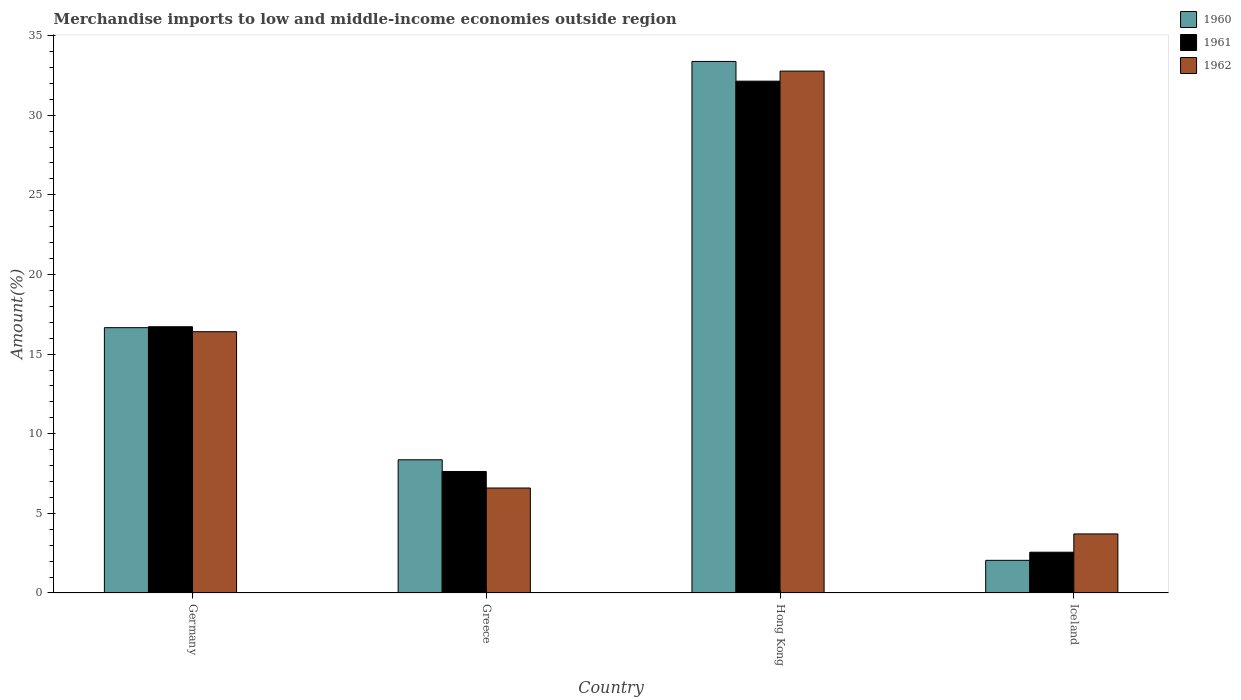How many different coloured bars are there?
Keep it short and to the point. 3. How many groups of bars are there?
Provide a succinct answer. 4. How many bars are there on the 4th tick from the left?
Offer a terse response. 3. What is the label of the 2nd group of bars from the left?
Your response must be concise. Greece. In how many cases, is the number of bars for a given country not equal to the number of legend labels?
Your response must be concise. 0. What is the percentage of amount earned from merchandise imports in 1960 in Greece?
Your response must be concise. 8.36. Across all countries, what is the maximum percentage of amount earned from merchandise imports in 1962?
Your answer should be very brief. 32.77. Across all countries, what is the minimum percentage of amount earned from merchandise imports in 1960?
Make the answer very short. 2.05. In which country was the percentage of amount earned from merchandise imports in 1962 maximum?
Your response must be concise. Hong Kong. In which country was the percentage of amount earned from merchandise imports in 1960 minimum?
Keep it short and to the point. Iceland. What is the total percentage of amount earned from merchandise imports in 1960 in the graph?
Keep it short and to the point. 60.44. What is the difference between the percentage of amount earned from merchandise imports in 1961 in Greece and that in Iceland?
Keep it short and to the point. 5.07. What is the difference between the percentage of amount earned from merchandise imports in 1960 in Greece and the percentage of amount earned from merchandise imports in 1962 in Germany?
Offer a terse response. -8.04. What is the average percentage of amount earned from merchandise imports in 1960 per country?
Your answer should be compact. 15.11. What is the difference between the percentage of amount earned from merchandise imports of/in 1962 and percentage of amount earned from merchandise imports of/in 1960 in Germany?
Your answer should be very brief. -0.25. What is the ratio of the percentage of amount earned from merchandise imports in 1962 in Germany to that in Hong Kong?
Keep it short and to the point. 0.5. Is the difference between the percentage of amount earned from merchandise imports in 1962 in Germany and Iceland greater than the difference between the percentage of amount earned from merchandise imports in 1960 in Germany and Iceland?
Keep it short and to the point. No. What is the difference between the highest and the second highest percentage of amount earned from merchandise imports in 1961?
Ensure brevity in your answer.  15.42. What is the difference between the highest and the lowest percentage of amount earned from merchandise imports in 1960?
Give a very brief answer. 31.32. What does the 2nd bar from the left in Greece represents?
Offer a terse response. 1961. What does the 2nd bar from the right in Hong Kong represents?
Your answer should be compact. 1961. How many bars are there?
Provide a succinct answer. 12. Are all the bars in the graph horizontal?
Your response must be concise. No. How many countries are there in the graph?
Your answer should be very brief. 4. What is the difference between two consecutive major ticks on the Y-axis?
Keep it short and to the point. 5. Does the graph contain grids?
Provide a succinct answer. No. Where does the legend appear in the graph?
Offer a terse response. Top right. How many legend labels are there?
Your answer should be very brief. 3. How are the legend labels stacked?
Offer a very short reply. Vertical. What is the title of the graph?
Give a very brief answer. Merchandise imports to low and middle-income economies outside region. Does "1974" appear as one of the legend labels in the graph?
Your answer should be very brief. No. What is the label or title of the X-axis?
Provide a succinct answer. Country. What is the label or title of the Y-axis?
Your response must be concise. Amount(%). What is the Amount(%) of 1960 in Germany?
Offer a terse response. 16.66. What is the Amount(%) of 1961 in Germany?
Provide a succinct answer. 16.72. What is the Amount(%) of 1962 in Germany?
Give a very brief answer. 16.41. What is the Amount(%) in 1960 in Greece?
Your response must be concise. 8.36. What is the Amount(%) of 1961 in Greece?
Keep it short and to the point. 7.63. What is the Amount(%) of 1962 in Greece?
Offer a very short reply. 6.59. What is the Amount(%) in 1960 in Hong Kong?
Your response must be concise. 33.37. What is the Amount(%) in 1961 in Hong Kong?
Make the answer very short. 32.13. What is the Amount(%) of 1962 in Hong Kong?
Provide a succinct answer. 32.77. What is the Amount(%) of 1960 in Iceland?
Offer a terse response. 2.05. What is the Amount(%) in 1961 in Iceland?
Provide a short and direct response. 2.56. What is the Amount(%) of 1962 in Iceland?
Offer a very short reply. 3.71. Across all countries, what is the maximum Amount(%) of 1960?
Provide a short and direct response. 33.37. Across all countries, what is the maximum Amount(%) in 1961?
Provide a succinct answer. 32.13. Across all countries, what is the maximum Amount(%) of 1962?
Provide a short and direct response. 32.77. Across all countries, what is the minimum Amount(%) in 1960?
Offer a very short reply. 2.05. Across all countries, what is the minimum Amount(%) of 1961?
Make the answer very short. 2.56. Across all countries, what is the minimum Amount(%) in 1962?
Provide a short and direct response. 3.71. What is the total Amount(%) of 1960 in the graph?
Offer a very short reply. 60.44. What is the total Amount(%) in 1961 in the graph?
Make the answer very short. 59.04. What is the total Amount(%) of 1962 in the graph?
Offer a very short reply. 59.47. What is the difference between the Amount(%) in 1960 in Germany and that in Greece?
Offer a very short reply. 8.3. What is the difference between the Amount(%) in 1961 in Germany and that in Greece?
Keep it short and to the point. 9.09. What is the difference between the Amount(%) in 1962 in Germany and that in Greece?
Keep it short and to the point. 9.81. What is the difference between the Amount(%) in 1960 in Germany and that in Hong Kong?
Give a very brief answer. -16.71. What is the difference between the Amount(%) in 1961 in Germany and that in Hong Kong?
Ensure brevity in your answer.  -15.42. What is the difference between the Amount(%) in 1962 in Germany and that in Hong Kong?
Keep it short and to the point. -16.36. What is the difference between the Amount(%) in 1960 in Germany and that in Iceland?
Offer a terse response. 14.61. What is the difference between the Amount(%) in 1961 in Germany and that in Iceland?
Make the answer very short. 14.15. What is the difference between the Amount(%) in 1962 in Germany and that in Iceland?
Provide a succinct answer. 12.7. What is the difference between the Amount(%) in 1960 in Greece and that in Hong Kong?
Provide a short and direct response. -25.01. What is the difference between the Amount(%) of 1961 in Greece and that in Hong Kong?
Ensure brevity in your answer.  -24.51. What is the difference between the Amount(%) in 1962 in Greece and that in Hong Kong?
Provide a succinct answer. -26.17. What is the difference between the Amount(%) in 1960 in Greece and that in Iceland?
Offer a very short reply. 6.31. What is the difference between the Amount(%) in 1961 in Greece and that in Iceland?
Offer a terse response. 5.07. What is the difference between the Amount(%) of 1962 in Greece and that in Iceland?
Ensure brevity in your answer.  2.88. What is the difference between the Amount(%) in 1960 in Hong Kong and that in Iceland?
Offer a terse response. 31.32. What is the difference between the Amount(%) in 1961 in Hong Kong and that in Iceland?
Provide a short and direct response. 29.57. What is the difference between the Amount(%) of 1962 in Hong Kong and that in Iceland?
Keep it short and to the point. 29.06. What is the difference between the Amount(%) in 1960 in Germany and the Amount(%) in 1961 in Greece?
Make the answer very short. 9.03. What is the difference between the Amount(%) of 1960 in Germany and the Amount(%) of 1962 in Greece?
Your answer should be very brief. 10.07. What is the difference between the Amount(%) of 1961 in Germany and the Amount(%) of 1962 in Greece?
Ensure brevity in your answer.  10.12. What is the difference between the Amount(%) in 1960 in Germany and the Amount(%) in 1961 in Hong Kong?
Give a very brief answer. -15.48. What is the difference between the Amount(%) in 1960 in Germany and the Amount(%) in 1962 in Hong Kong?
Your answer should be very brief. -16.11. What is the difference between the Amount(%) of 1961 in Germany and the Amount(%) of 1962 in Hong Kong?
Make the answer very short. -16.05. What is the difference between the Amount(%) in 1960 in Germany and the Amount(%) in 1961 in Iceland?
Make the answer very short. 14.1. What is the difference between the Amount(%) in 1960 in Germany and the Amount(%) in 1962 in Iceland?
Provide a short and direct response. 12.95. What is the difference between the Amount(%) of 1961 in Germany and the Amount(%) of 1962 in Iceland?
Your answer should be compact. 13.01. What is the difference between the Amount(%) in 1960 in Greece and the Amount(%) in 1961 in Hong Kong?
Provide a short and direct response. -23.77. What is the difference between the Amount(%) of 1960 in Greece and the Amount(%) of 1962 in Hong Kong?
Offer a terse response. -24.4. What is the difference between the Amount(%) in 1961 in Greece and the Amount(%) in 1962 in Hong Kong?
Provide a succinct answer. -25.14. What is the difference between the Amount(%) in 1960 in Greece and the Amount(%) in 1961 in Iceland?
Offer a very short reply. 5.8. What is the difference between the Amount(%) of 1960 in Greece and the Amount(%) of 1962 in Iceland?
Offer a terse response. 4.66. What is the difference between the Amount(%) of 1961 in Greece and the Amount(%) of 1962 in Iceland?
Provide a short and direct response. 3.92. What is the difference between the Amount(%) in 1960 in Hong Kong and the Amount(%) in 1961 in Iceland?
Keep it short and to the point. 30.81. What is the difference between the Amount(%) in 1960 in Hong Kong and the Amount(%) in 1962 in Iceland?
Ensure brevity in your answer.  29.66. What is the difference between the Amount(%) in 1961 in Hong Kong and the Amount(%) in 1962 in Iceland?
Provide a succinct answer. 28.43. What is the average Amount(%) of 1960 per country?
Make the answer very short. 15.11. What is the average Amount(%) of 1961 per country?
Keep it short and to the point. 14.76. What is the average Amount(%) in 1962 per country?
Provide a succinct answer. 14.87. What is the difference between the Amount(%) in 1960 and Amount(%) in 1961 in Germany?
Your response must be concise. -0.06. What is the difference between the Amount(%) of 1960 and Amount(%) of 1962 in Germany?
Make the answer very short. 0.25. What is the difference between the Amount(%) of 1961 and Amount(%) of 1962 in Germany?
Offer a very short reply. 0.31. What is the difference between the Amount(%) of 1960 and Amount(%) of 1961 in Greece?
Your answer should be very brief. 0.73. What is the difference between the Amount(%) in 1960 and Amount(%) in 1962 in Greece?
Your answer should be compact. 1.77. What is the difference between the Amount(%) of 1961 and Amount(%) of 1962 in Greece?
Keep it short and to the point. 1.04. What is the difference between the Amount(%) of 1960 and Amount(%) of 1961 in Hong Kong?
Provide a short and direct response. 1.24. What is the difference between the Amount(%) of 1960 and Amount(%) of 1962 in Hong Kong?
Offer a terse response. 0.61. What is the difference between the Amount(%) in 1961 and Amount(%) in 1962 in Hong Kong?
Your answer should be compact. -0.63. What is the difference between the Amount(%) in 1960 and Amount(%) in 1961 in Iceland?
Keep it short and to the point. -0.51. What is the difference between the Amount(%) of 1960 and Amount(%) of 1962 in Iceland?
Your answer should be compact. -1.66. What is the difference between the Amount(%) of 1961 and Amount(%) of 1962 in Iceland?
Offer a very short reply. -1.15. What is the ratio of the Amount(%) in 1960 in Germany to that in Greece?
Provide a succinct answer. 1.99. What is the ratio of the Amount(%) of 1961 in Germany to that in Greece?
Give a very brief answer. 2.19. What is the ratio of the Amount(%) of 1962 in Germany to that in Greece?
Give a very brief answer. 2.49. What is the ratio of the Amount(%) in 1960 in Germany to that in Hong Kong?
Your answer should be very brief. 0.5. What is the ratio of the Amount(%) in 1961 in Germany to that in Hong Kong?
Provide a short and direct response. 0.52. What is the ratio of the Amount(%) in 1962 in Germany to that in Hong Kong?
Provide a short and direct response. 0.5. What is the ratio of the Amount(%) of 1960 in Germany to that in Iceland?
Ensure brevity in your answer.  8.13. What is the ratio of the Amount(%) in 1961 in Germany to that in Iceland?
Your answer should be very brief. 6.53. What is the ratio of the Amount(%) in 1962 in Germany to that in Iceland?
Ensure brevity in your answer.  4.42. What is the ratio of the Amount(%) in 1960 in Greece to that in Hong Kong?
Keep it short and to the point. 0.25. What is the ratio of the Amount(%) of 1961 in Greece to that in Hong Kong?
Offer a very short reply. 0.24. What is the ratio of the Amount(%) in 1962 in Greece to that in Hong Kong?
Give a very brief answer. 0.2. What is the ratio of the Amount(%) in 1960 in Greece to that in Iceland?
Ensure brevity in your answer.  4.08. What is the ratio of the Amount(%) of 1961 in Greece to that in Iceland?
Make the answer very short. 2.98. What is the ratio of the Amount(%) in 1962 in Greece to that in Iceland?
Offer a very short reply. 1.78. What is the ratio of the Amount(%) of 1960 in Hong Kong to that in Iceland?
Offer a very short reply. 16.28. What is the ratio of the Amount(%) in 1961 in Hong Kong to that in Iceland?
Keep it short and to the point. 12.55. What is the ratio of the Amount(%) of 1962 in Hong Kong to that in Iceland?
Offer a terse response. 8.84. What is the difference between the highest and the second highest Amount(%) of 1960?
Give a very brief answer. 16.71. What is the difference between the highest and the second highest Amount(%) of 1961?
Your response must be concise. 15.42. What is the difference between the highest and the second highest Amount(%) in 1962?
Keep it short and to the point. 16.36. What is the difference between the highest and the lowest Amount(%) in 1960?
Provide a short and direct response. 31.32. What is the difference between the highest and the lowest Amount(%) in 1961?
Your answer should be very brief. 29.57. What is the difference between the highest and the lowest Amount(%) of 1962?
Offer a very short reply. 29.06. 